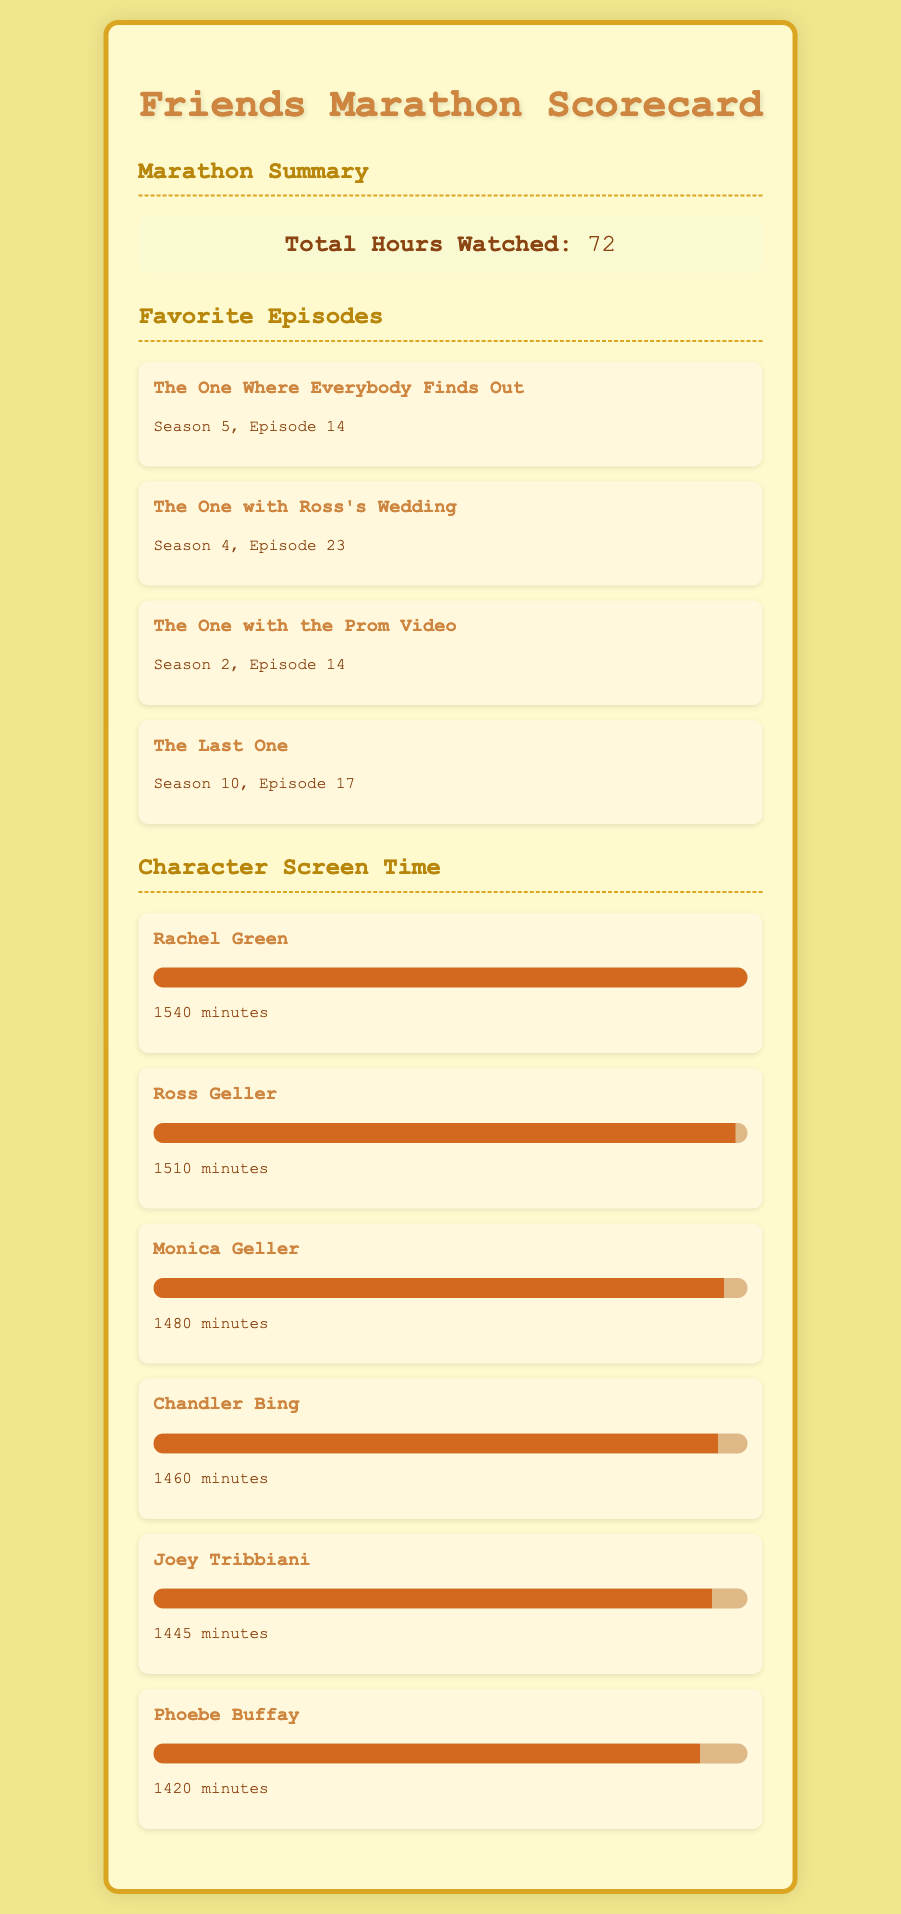What is the total hours watched? The total hours watched is directly stated in the document as the main summary of the marathon.
Answer: 72 Which episode from Season 5 is listed as a favorite? The document lists favorite episodes, and the one from Season 5 is "The One Where Everybody Finds Out."
Answer: The One Where Everybody Finds Out Who has the most screen time? The character with the most screen time is identified in the character screen time section of the document.
Answer: Rachel Green How many minutes of screen time does Ross Geller have? The document specifies the amount of screen time each character has, with Ross Geller having 1510 minutes.
Answer: 1510 minutes What episode is "The Last One"? The document includes favorite episodes, and "The Last One" is mentioned along with its corresponding season and episode number.
Answer: Season 10, Episode 17 What percentage of screen time does Phoebe Buffay have? The progress bars in the character screen time section represent the screen time percentages, with Phoebe Buffay at 92%.
Answer: 92% What is the total screen time of all main characters combined? While not specifically asked in the document, one can infer the total screen time by summing the individual characters' screen times provided in the document.
Answer: 8645 minutes Which episode is the last in the list of favorite episodes? The favorite episodes are listed in a specific order, with the last one being "The Last One."
Answer: The Last One How many minutes of screen time does Monica Geller have? The document states the screen time for Monica Geller, allowing us to directly answer this question.
Answer: 1480 minutes 